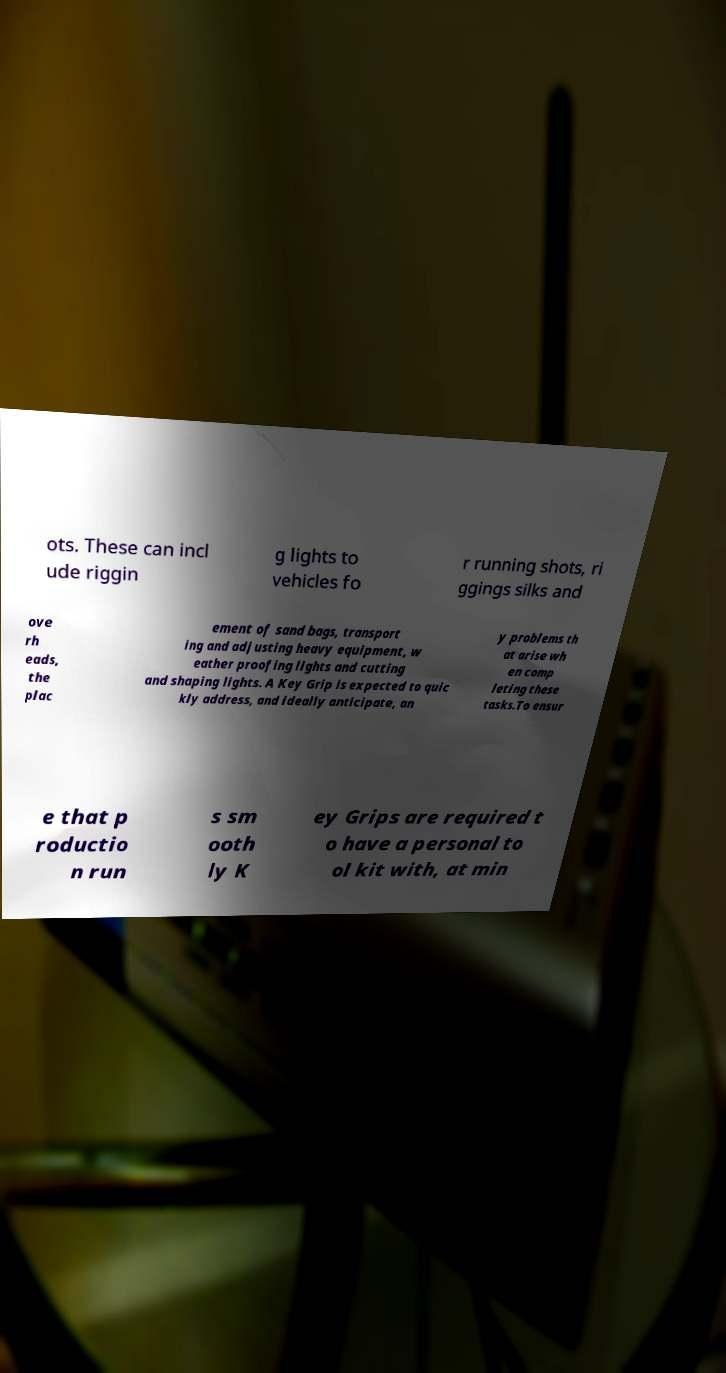Could you assist in decoding the text presented in this image and type it out clearly? ots. These can incl ude riggin g lights to vehicles fo r running shots, ri ggings silks and ove rh eads, the plac ement of sand bags, transport ing and adjusting heavy equipment, w eather proofing lights and cutting and shaping lights. A Key Grip is expected to quic kly address, and ideally anticipate, an y problems th at arise wh en comp leting these tasks.To ensur e that p roductio n run s sm ooth ly K ey Grips are required t o have a personal to ol kit with, at min 